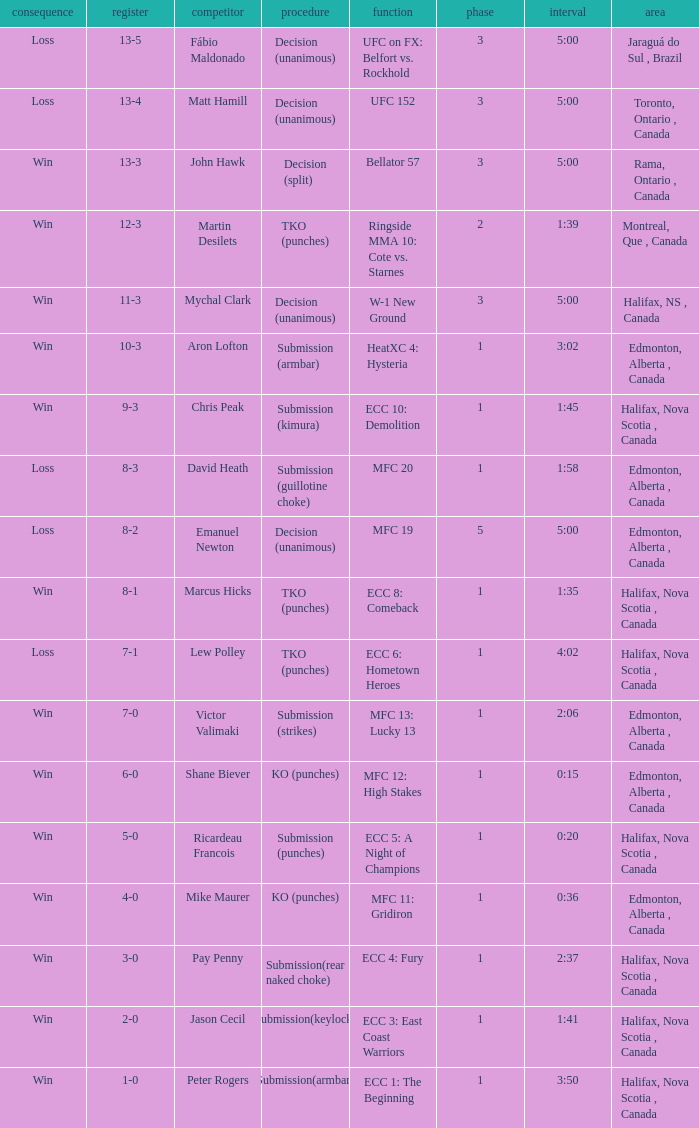What is the location of the match with an event of ecc 8: comeback? Halifax, Nova Scotia , Canada. 